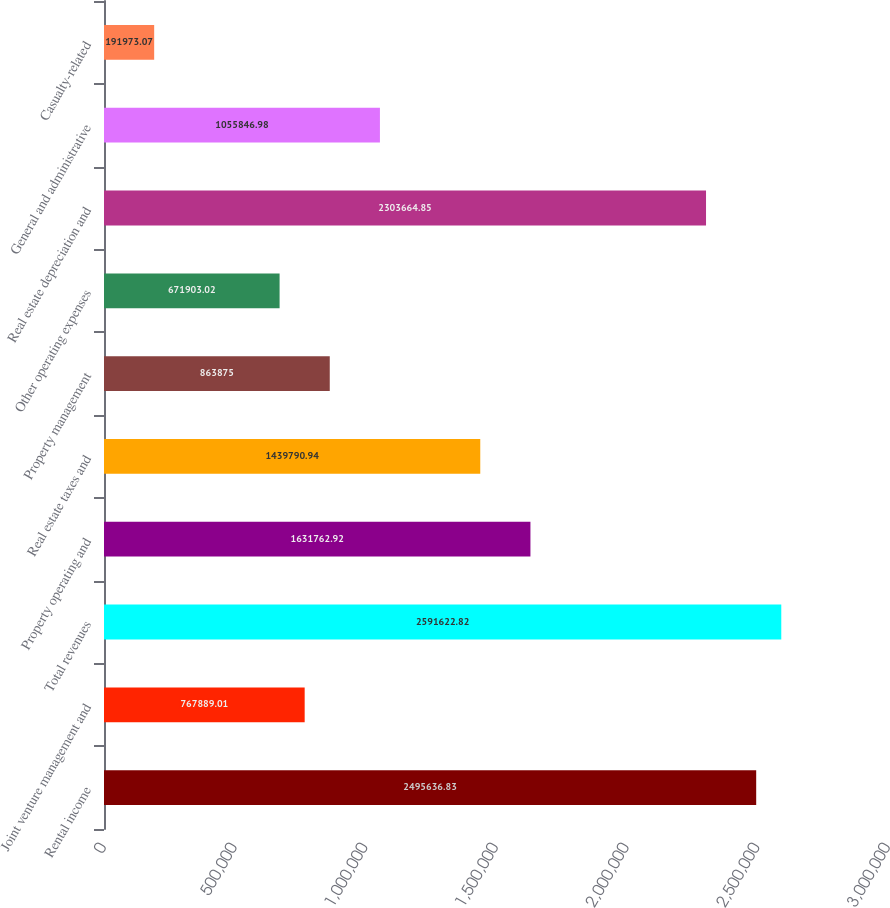Convert chart. <chart><loc_0><loc_0><loc_500><loc_500><bar_chart><fcel>Rental income<fcel>Joint venture management and<fcel>Total revenues<fcel>Property operating and<fcel>Real estate taxes and<fcel>Property management<fcel>Other operating expenses<fcel>Real estate depreciation and<fcel>General and administrative<fcel>Casualty-related<nl><fcel>2.49564e+06<fcel>767889<fcel>2.59162e+06<fcel>1.63176e+06<fcel>1.43979e+06<fcel>863875<fcel>671903<fcel>2.30366e+06<fcel>1.05585e+06<fcel>191973<nl></chart> 